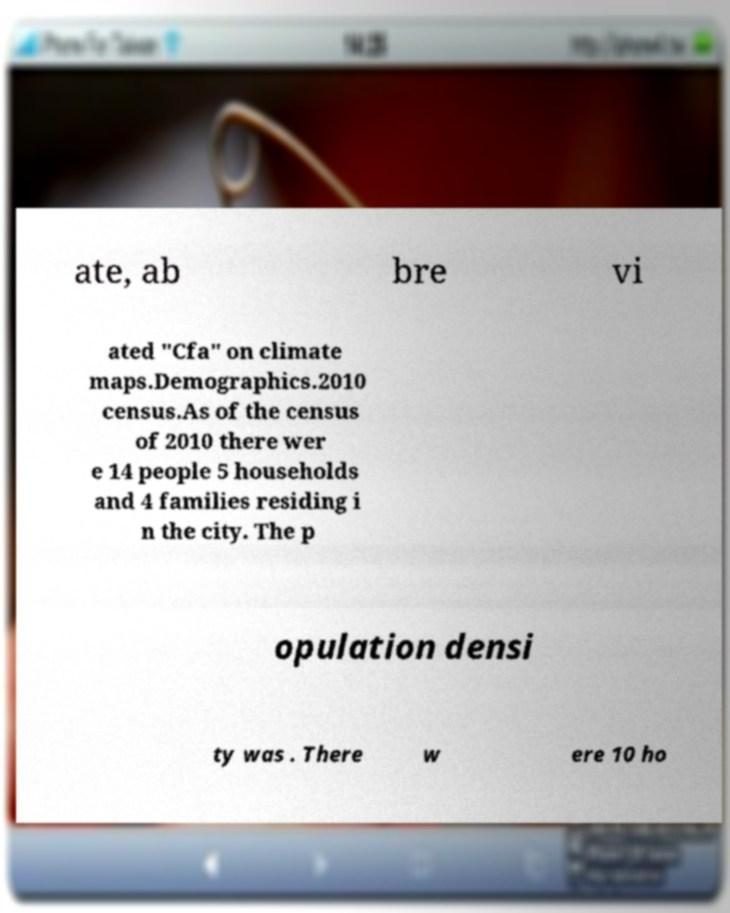Can you accurately transcribe the text from the provided image for me? ate, ab bre vi ated "Cfa" on climate maps.Demographics.2010 census.As of the census of 2010 there wer e 14 people 5 households and 4 families residing i n the city. The p opulation densi ty was . There w ere 10 ho 